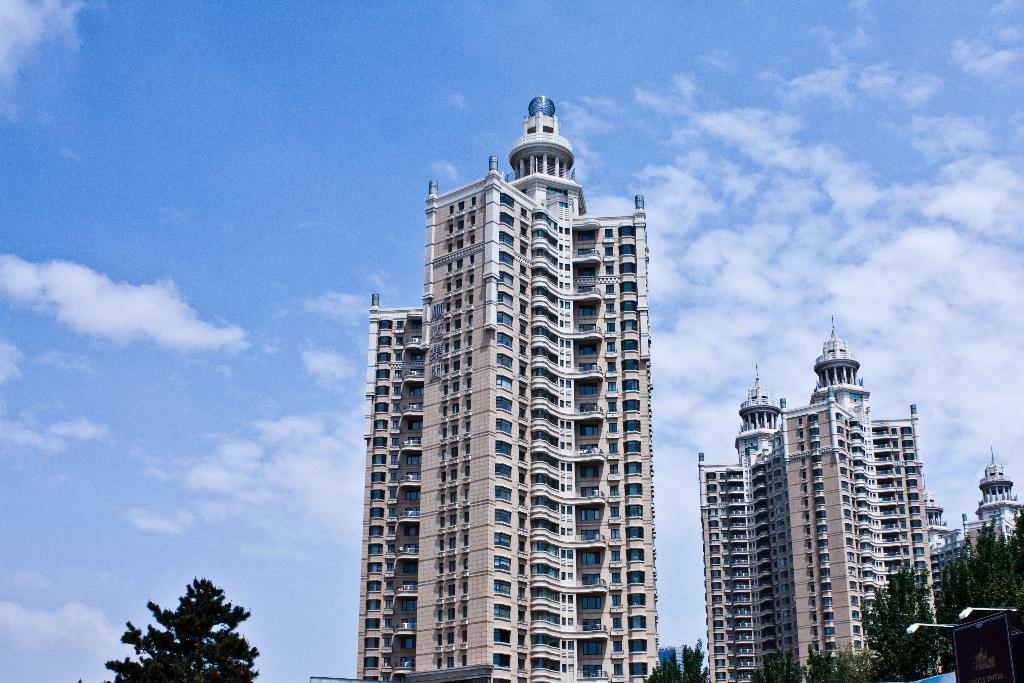Can you describe this image briefly? In this image we can see a group of buildings, trees and poles. On the right side of the image we can see a poster. In the background, we can see the cloudy sky. 